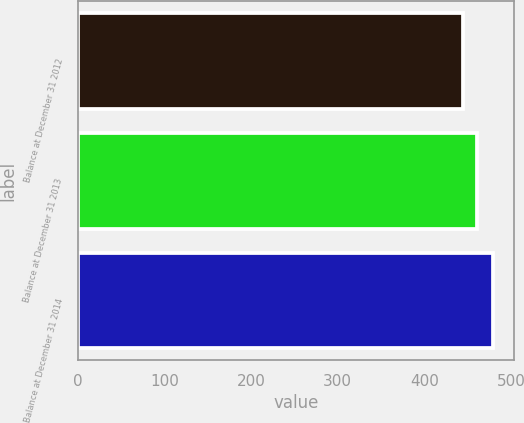Convert chart to OTSL. <chart><loc_0><loc_0><loc_500><loc_500><bar_chart><fcel>Balance at December 31 2012<fcel>Balance at December 31 2013<fcel>Balance at December 31 2014<nl><fcel>445<fcel>461<fcel>479<nl></chart> 